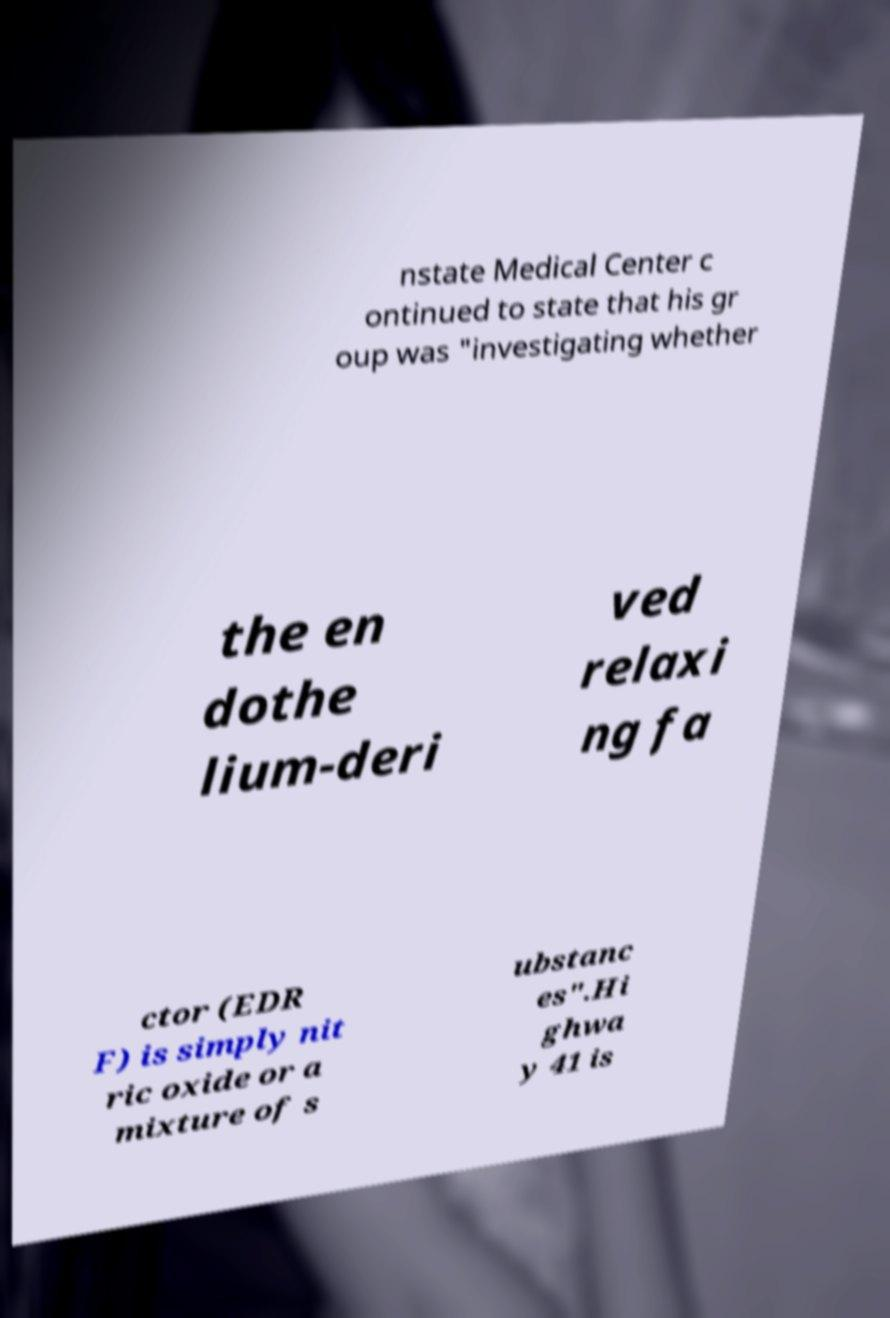Can you accurately transcribe the text from the provided image for me? nstate Medical Center c ontinued to state that his gr oup was "investigating whether the en dothe lium-deri ved relaxi ng fa ctor (EDR F) is simply nit ric oxide or a mixture of s ubstanc es".Hi ghwa y 41 is 